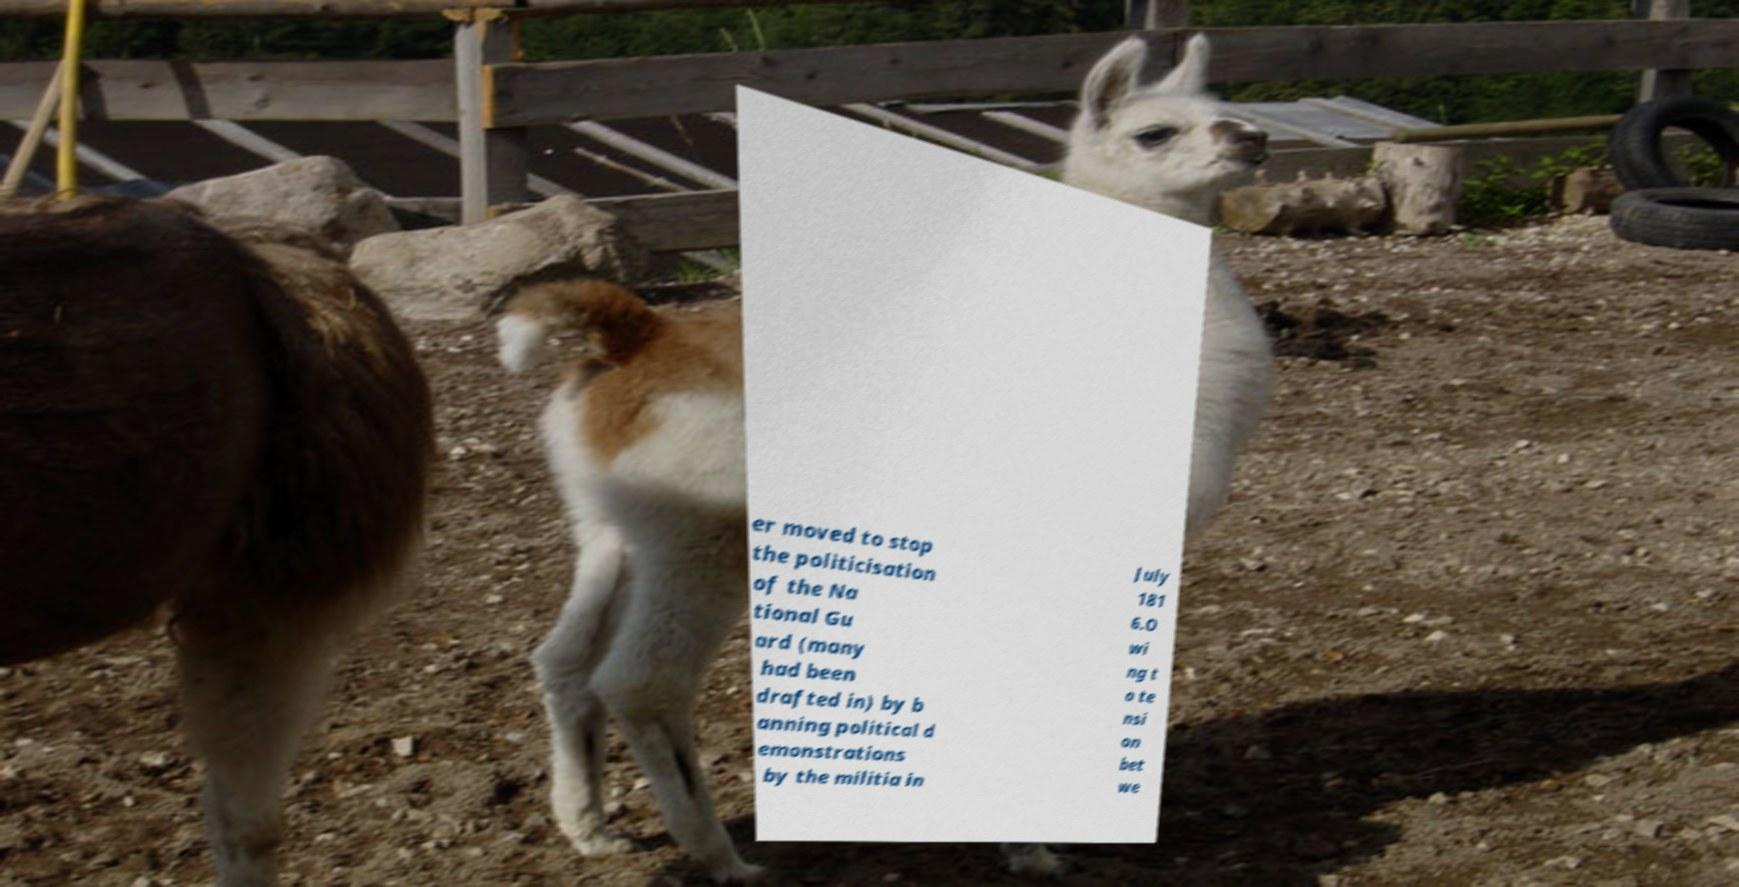Could you extract and type out the text from this image? er moved to stop the politicisation of the Na tional Gu ard (many had been drafted in) by b anning political d emonstrations by the militia in July 181 6.O wi ng t o te nsi on bet we 